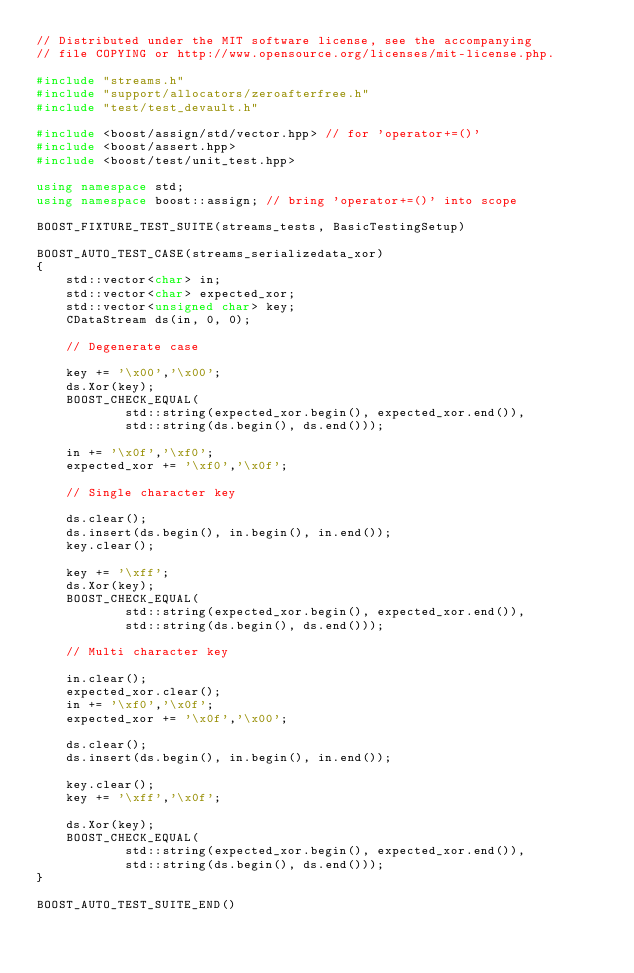<code> <loc_0><loc_0><loc_500><loc_500><_C++_>// Distributed under the MIT software license, see the accompanying
// file COPYING or http://www.opensource.org/licenses/mit-license.php.

#include "streams.h"
#include "support/allocators/zeroafterfree.h"
#include "test/test_devault.h"

#include <boost/assign/std/vector.hpp> // for 'operator+=()'
#include <boost/assert.hpp>
#include <boost/test/unit_test.hpp>
                    
using namespace std;
using namespace boost::assign; // bring 'operator+=()' into scope

BOOST_FIXTURE_TEST_SUITE(streams_tests, BasicTestingSetup)

BOOST_AUTO_TEST_CASE(streams_serializedata_xor)
{
    std::vector<char> in;
    std::vector<char> expected_xor;
    std::vector<unsigned char> key;
    CDataStream ds(in, 0, 0);

    // Degenerate case
    
    key += '\x00','\x00';
    ds.Xor(key);
    BOOST_CHECK_EQUAL(
            std::string(expected_xor.begin(), expected_xor.end()), 
            std::string(ds.begin(), ds.end()));

    in += '\x0f','\xf0';
    expected_xor += '\xf0','\x0f';
    
    // Single character key

    ds.clear();
    ds.insert(ds.begin(), in.begin(), in.end());
    key.clear();

    key += '\xff';
    ds.Xor(key);
    BOOST_CHECK_EQUAL(
            std::string(expected_xor.begin(), expected_xor.end()), 
            std::string(ds.begin(), ds.end())); 
    
    // Multi character key

    in.clear();
    expected_xor.clear();
    in += '\xf0','\x0f';
    expected_xor += '\x0f','\x00';
                        
    ds.clear();
    ds.insert(ds.begin(), in.begin(), in.end());

    key.clear();
    key += '\xff','\x0f';

    ds.Xor(key);
    BOOST_CHECK_EQUAL(
            std::string(expected_xor.begin(), expected_xor.end()), 
            std::string(ds.begin(), ds.end()));  
}         

BOOST_AUTO_TEST_SUITE_END()
</code> 